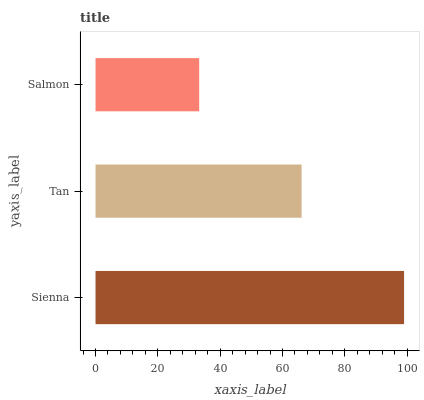Is Salmon the minimum?
Answer yes or no. Yes. Is Sienna the maximum?
Answer yes or no. Yes. Is Tan the minimum?
Answer yes or no. No. Is Tan the maximum?
Answer yes or no. No. Is Sienna greater than Tan?
Answer yes or no. Yes. Is Tan less than Sienna?
Answer yes or no. Yes. Is Tan greater than Sienna?
Answer yes or no. No. Is Sienna less than Tan?
Answer yes or no. No. Is Tan the high median?
Answer yes or no. Yes. Is Tan the low median?
Answer yes or no. Yes. Is Sienna the high median?
Answer yes or no. No. Is Sienna the low median?
Answer yes or no. No. 